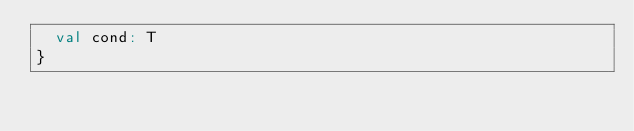Convert code to text. <code><loc_0><loc_0><loc_500><loc_500><_Scala_>  val cond: T
}
</code> 